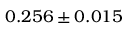<formula> <loc_0><loc_0><loc_500><loc_500>0 . 2 5 6 \pm 0 . 0 1 5</formula> 